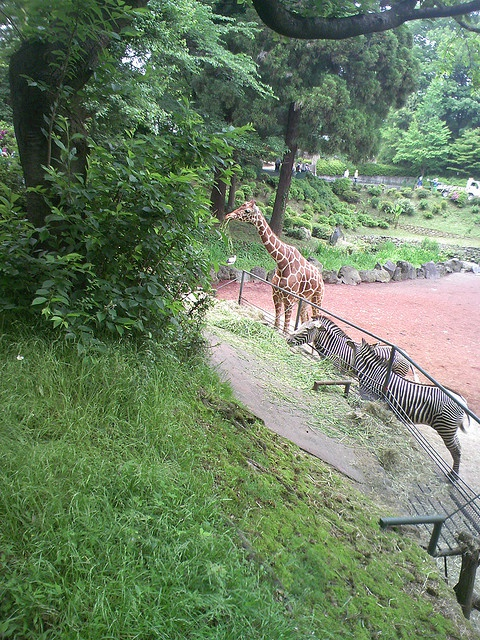Describe the objects in this image and their specific colors. I can see zebra in purple, black, white, gray, and darkgray tones, giraffe in purple, white, brown, lightpink, and darkgray tones, zebra in purple, white, gray, darkgray, and black tones, people in purple, white, darkgray, gray, and olive tones, and people in purple, white, lavender, teal, and blue tones in this image. 